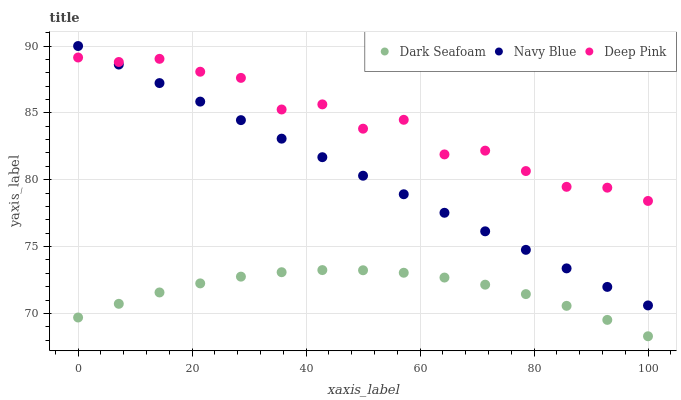Does Dark Seafoam have the minimum area under the curve?
Answer yes or no. Yes. Does Deep Pink have the maximum area under the curve?
Answer yes or no. Yes. Does Deep Pink have the minimum area under the curve?
Answer yes or no. No. Does Dark Seafoam have the maximum area under the curve?
Answer yes or no. No. Is Navy Blue the smoothest?
Answer yes or no. Yes. Is Deep Pink the roughest?
Answer yes or no. Yes. Is Dark Seafoam the smoothest?
Answer yes or no. No. Is Dark Seafoam the roughest?
Answer yes or no. No. Does Dark Seafoam have the lowest value?
Answer yes or no. Yes. Does Deep Pink have the lowest value?
Answer yes or no. No. Does Navy Blue have the highest value?
Answer yes or no. Yes. Does Deep Pink have the highest value?
Answer yes or no. No. Is Dark Seafoam less than Deep Pink?
Answer yes or no. Yes. Is Navy Blue greater than Dark Seafoam?
Answer yes or no. Yes. Does Deep Pink intersect Navy Blue?
Answer yes or no. Yes. Is Deep Pink less than Navy Blue?
Answer yes or no. No. Is Deep Pink greater than Navy Blue?
Answer yes or no. No. Does Dark Seafoam intersect Deep Pink?
Answer yes or no. No. 